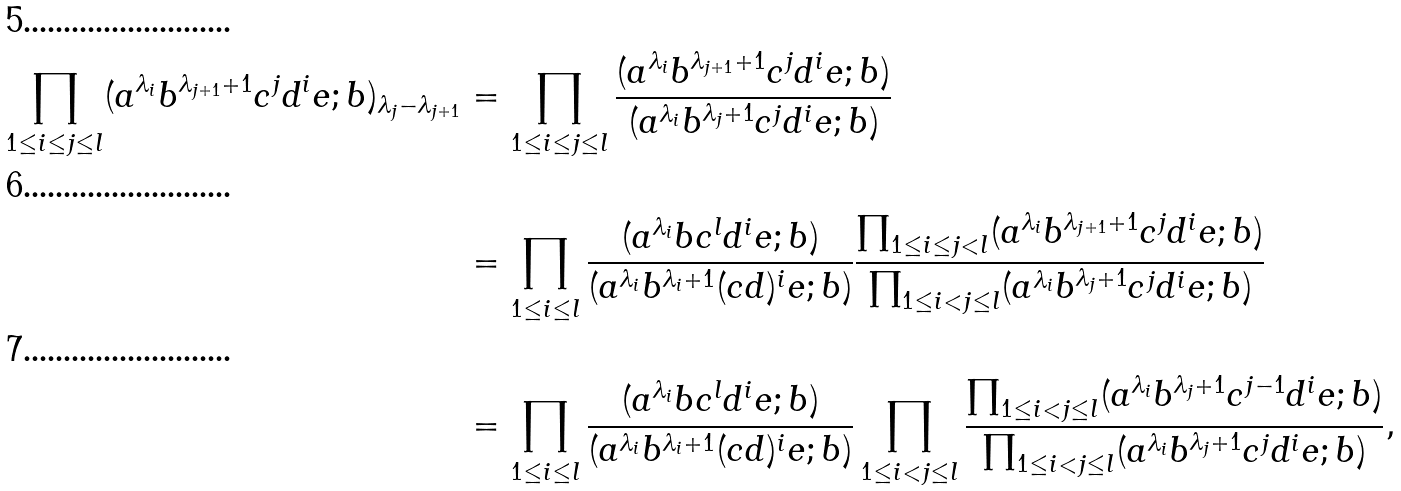<formula> <loc_0><loc_0><loc_500><loc_500>\prod _ { 1 \leq i \leq j \leq l } ( a ^ { \lambda _ { i } } b ^ { \lambda _ { j + 1 } + 1 } c ^ { j } d ^ { i } e ; b ) _ { \lambda _ { j } - \lambda _ { j + 1 } } & = \prod _ { 1 \leq i \leq j \leq l } \frac { ( a ^ { \lambda _ { i } } b ^ { \lambda _ { j + 1 } + 1 } c ^ { j } d ^ { i } e ; b ) } { ( a ^ { \lambda _ { i } } b ^ { \lambda _ { j } + 1 } c ^ { j } d ^ { i } e ; b ) } \\ & = \prod _ { 1 \leq i \leq l } \frac { ( a ^ { \lambda _ { i } } b c ^ { l } d ^ { i } e ; b ) } { ( a ^ { \lambda _ { i } } b ^ { \lambda _ { i } + 1 } ( c d ) ^ { i } e ; b ) } \frac { \prod _ { 1 \leq i \leq j < l } ( a ^ { \lambda _ { i } } b ^ { \lambda _ { j + 1 } + 1 } c ^ { j } d ^ { i } e ; b ) } { \prod _ { 1 \leq i < j \leq l } ( a ^ { \lambda _ { i } } b ^ { \lambda _ { j } + 1 } c ^ { j } d ^ { i } e ; b ) } \\ & = \prod _ { 1 \leq i \leq l } \frac { ( a ^ { \lambda _ { i } } b c ^ { l } d ^ { i } e ; b ) } { ( a ^ { \lambda _ { i } } b ^ { \lambda _ { i } + 1 } ( c d ) ^ { i } e ; b ) } \prod _ { 1 \leq i < j \leq l } \frac { \prod _ { 1 \leq i < j \leq l } ( a ^ { \lambda _ { i } } b ^ { \lambda _ { j } + 1 } c ^ { j - 1 } d ^ { i } e ; b ) } { \prod _ { 1 \leq i < j \leq l } ( a ^ { \lambda _ { i } } b ^ { \lambda _ { j } + 1 } c ^ { j } d ^ { i } e ; b ) } ,</formula> 